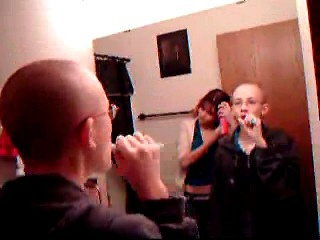Describe the objects in this image and their specific colors. I can see people in gray, black, maroon, brown, and salmon tones, people in gray, black, salmon, brown, and maroon tones, people in gray, black, maroon, lightpink, and brown tones, hair drier in gray, salmon, maroon, red, and brown tones, and toothbrush in gray, lightpink, brown, and tan tones in this image. 